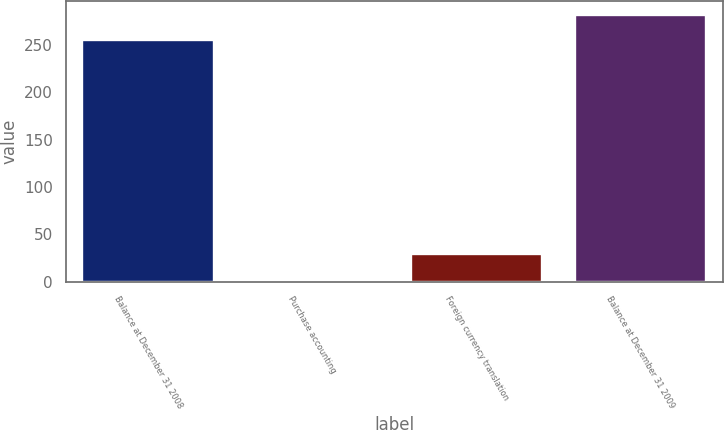Convert chart. <chart><loc_0><loc_0><loc_500><loc_500><bar_chart><fcel>Balance at December 31 2008<fcel>Purchase accounting<fcel>Foreign currency translation<fcel>Balance at December 31 2009<nl><fcel>255<fcel>2<fcel>29.1<fcel>282.1<nl></chart> 